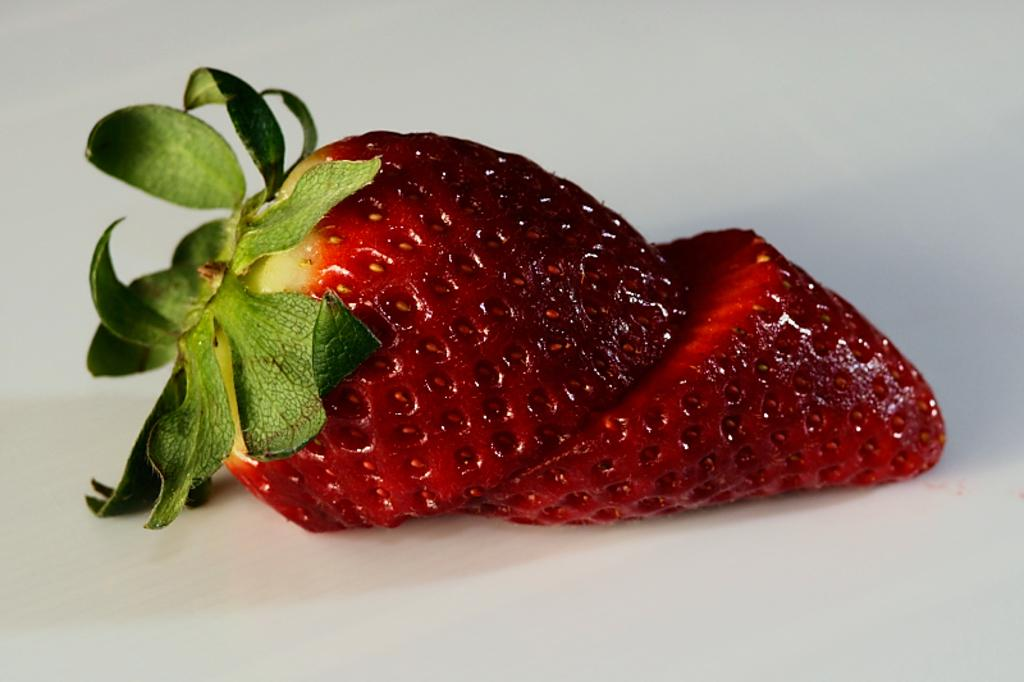What type of fruit is visible in the image? There is a sliced strawberry in the image. What route does the cat take to reach the feast in the image? There is no cat or feast present in the image; it only features a sliced strawberry. 